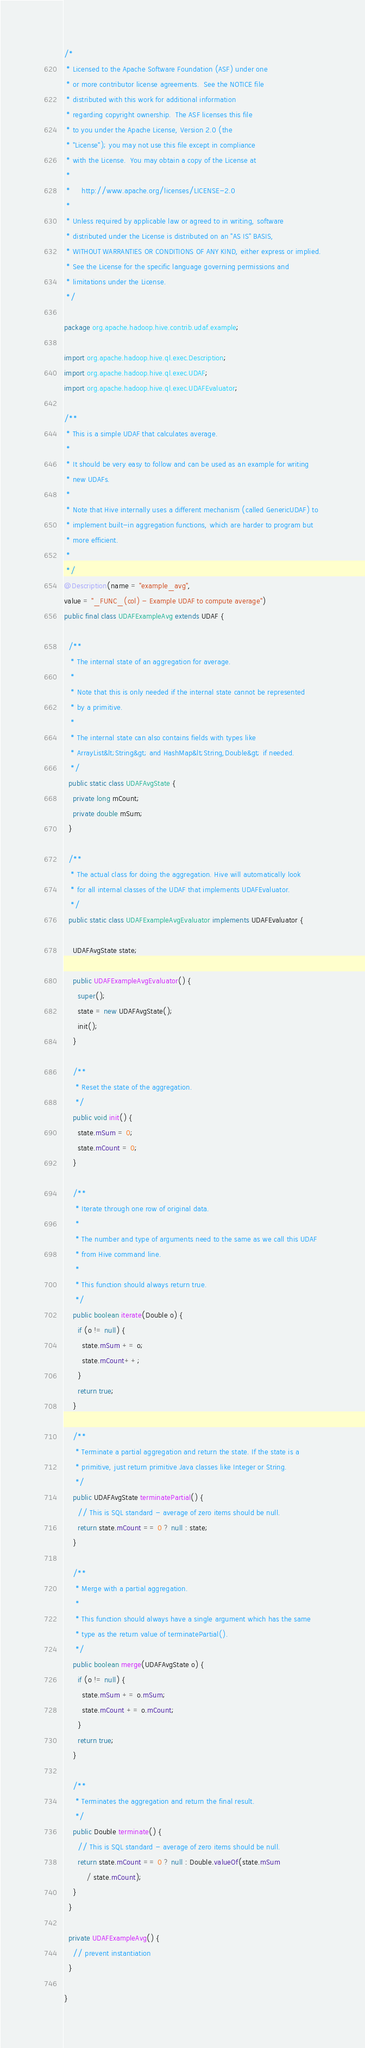Convert code to text. <code><loc_0><loc_0><loc_500><loc_500><_Java_>/*
 * Licensed to the Apache Software Foundation (ASF) under one
 * or more contributor license agreements.  See the NOTICE file
 * distributed with this work for additional information
 * regarding copyright ownership.  The ASF licenses this file
 * to you under the Apache License, Version 2.0 (the
 * "License"); you may not use this file except in compliance
 * with the License.  You may obtain a copy of the License at
 *
 *     http://www.apache.org/licenses/LICENSE-2.0
 *
 * Unless required by applicable law or agreed to in writing, software
 * distributed under the License is distributed on an "AS IS" BASIS,
 * WITHOUT WARRANTIES OR CONDITIONS OF ANY KIND, either express or implied.
 * See the License for the specific language governing permissions and
 * limitations under the License.
 */

package org.apache.hadoop.hive.contrib.udaf.example;

import org.apache.hadoop.hive.ql.exec.Description;
import org.apache.hadoop.hive.ql.exec.UDAF;
import org.apache.hadoop.hive.ql.exec.UDAFEvaluator;

/**
 * This is a simple UDAF that calculates average.
 * 
 * It should be very easy to follow and can be used as an example for writing
 * new UDAFs.
 * 
 * Note that Hive internally uses a different mechanism (called GenericUDAF) to
 * implement built-in aggregation functions, which are harder to program but
 * more efficient.
 * 
 */
@Description(name = "example_avg",
value = "_FUNC_(col) - Example UDAF to compute average")
public final class UDAFExampleAvg extends UDAF {

  /**
   * The internal state of an aggregation for average.
   * 
   * Note that this is only needed if the internal state cannot be represented
   * by a primitive.
   * 
   * The internal state can also contains fields with types like
   * ArrayList&lt;String&gt; and HashMap&lt;String,Double&gt; if needed.
   */
  public static class UDAFAvgState {
    private long mCount;
    private double mSum;
  }

  /**
   * The actual class for doing the aggregation. Hive will automatically look
   * for all internal classes of the UDAF that implements UDAFEvaluator.
   */
  public static class UDAFExampleAvgEvaluator implements UDAFEvaluator {

    UDAFAvgState state;

    public UDAFExampleAvgEvaluator() {
      super();
      state = new UDAFAvgState();
      init();
    }

    /**
     * Reset the state of the aggregation.
     */
    public void init() {
      state.mSum = 0;
      state.mCount = 0;
    }

    /**
     * Iterate through one row of original data.
     * 
     * The number and type of arguments need to the same as we call this UDAF
     * from Hive command line.
     * 
     * This function should always return true.
     */
    public boolean iterate(Double o) {
      if (o != null) {
        state.mSum += o;
        state.mCount++;
      }
      return true;
    }

    /**
     * Terminate a partial aggregation and return the state. If the state is a
     * primitive, just return primitive Java classes like Integer or String.
     */
    public UDAFAvgState terminatePartial() {
      // This is SQL standard - average of zero items should be null.
      return state.mCount == 0 ? null : state;
    }

    /**
     * Merge with a partial aggregation.
     * 
     * This function should always have a single argument which has the same
     * type as the return value of terminatePartial().
     */
    public boolean merge(UDAFAvgState o) {
      if (o != null) {
        state.mSum += o.mSum;
        state.mCount += o.mCount;
      }
      return true;
    }

    /**
     * Terminates the aggregation and return the final result.
     */
    public Double terminate() {
      // This is SQL standard - average of zero items should be null.
      return state.mCount == 0 ? null : Double.valueOf(state.mSum
          / state.mCount);
    }
  }

  private UDAFExampleAvg() {
    // prevent instantiation
  }

}
</code> 